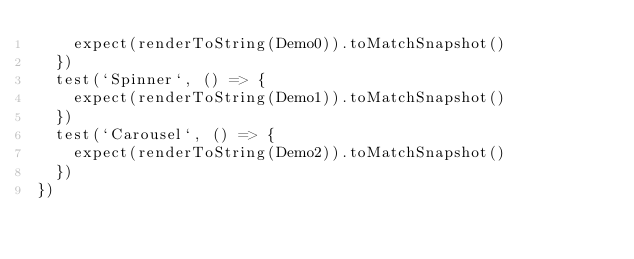<code> <loc_0><loc_0><loc_500><loc_500><_JavaScript_>    expect(renderToString(Demo0)).toMatchSnapshot()
  })
  test(`Spinner`, () => {
    expect(renderToString(Demo1)).toMatchSnapshot()
  })
  test(`Carousel`, () => {
    expect(renderToString(Demo2)).toMatchSnapshot()
  })
})
</code> 